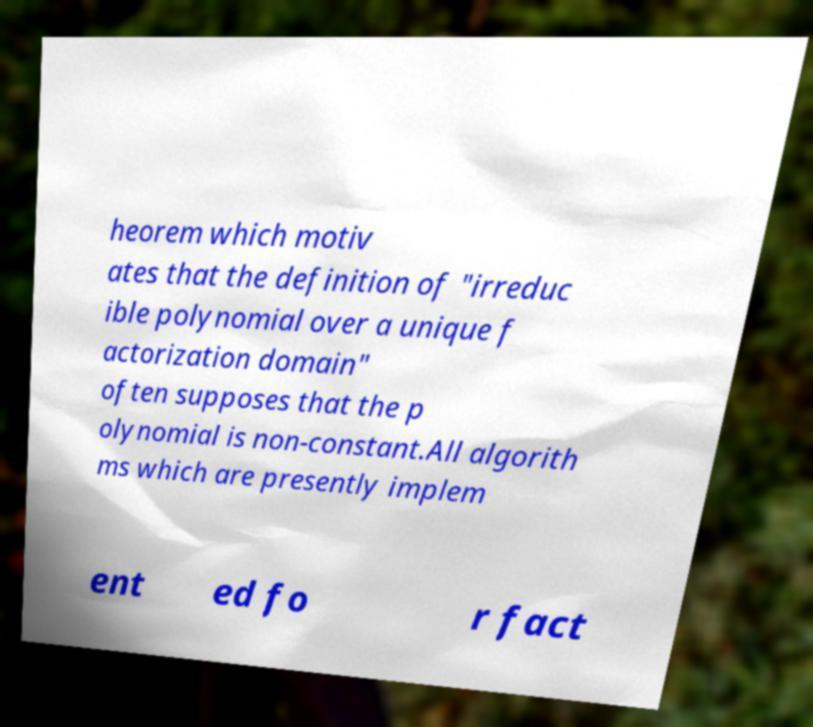For documentation purposes, I need the text within this image transcribed. Could you provide that? heorem which motiv ates that the definition of "irreduc ible polynomial over a unique f actorization domain" often supposes that the p olynomial is non-constant.All algorith ms which are presently implem ent ed fo r fact 